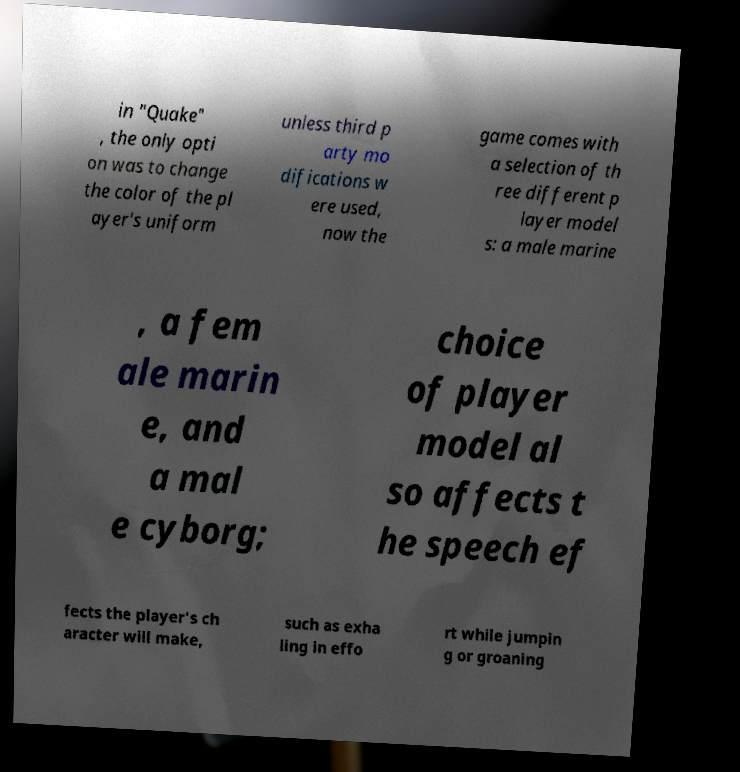Can you read and provide the text displayed in the image?This photo seems to have some interesting text. Can you extract and type it out for me? in "Quake" , the only opti on was to change the color of the pl ayer's uniform unless third p arty mo difications w ere used, now the game comes with a selection of th ree different p layer model s: a male marine , a fem ale marin e, and a mal e cyborg; choice of player model al so affects t he speech ef fects the player's ch aracter will make, such as exha ling in effo rt while jumpin g or groaning 